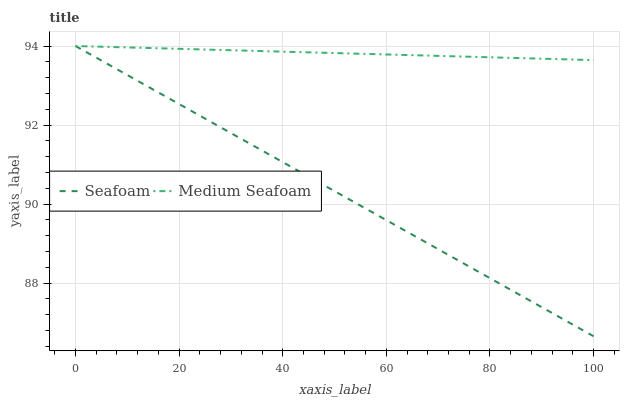Does Seafoam have the minimum area under the curve?
Answer yes or no. Yes. Does Medium Seafoam have the maximum area under the curve?
Answer yes or no. Yes. Does Medium Seafoam have the minimum area under the curve?
Answer yes or no. No. Is Medium Seafoam the smoothest?
Answer yes or no. Yes. Is Seafoam the roughest?
Answer yes or no. Yes. Is Medium Seafoam the roughest?
Answer yes or no. No. Does Seafoam have the lowest value?
Answer yes or no. Yes. Does Medium Seafoam have the lowest value?
Answer yes or no. No. Does Medium Seafoam have the highest value?
Answer yes or no. Yes. Does Medium Seafoam intersect Seafoam?
Answer yes or no. Yes. Is Medium Seafoam less than Seafoam?
Answer yes or no. No. Is Medium Seafoam greater than Seafoam?
Answer yes or no. No. 